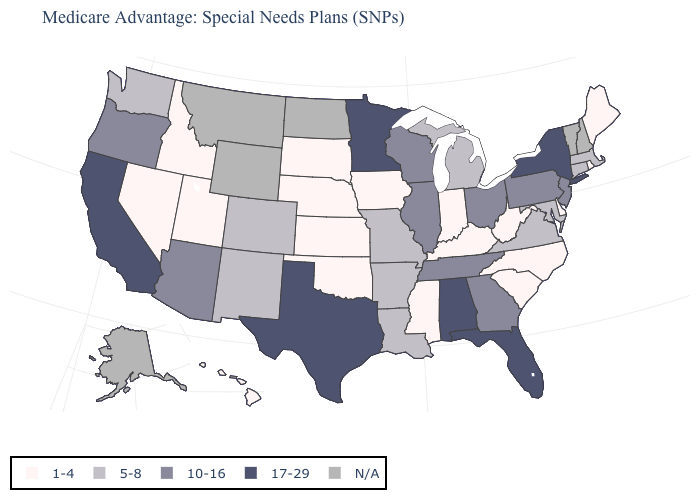Does Iowa have the lowest value in the USA?
Be succinct. Yes. Name the states that have a value in the range N/A?
Quick response, please. Alaska, Montana, North Dakota, New Hampshire, Vermont, Wyoming. Does the first symbol in the legend represent the smallest category?
Concise answer only. Yes. What is the value of Missouri?
Answer briefly. 5-8. Which states have the lowest value in the MidWest?
Give a very brief answer. Iowa, Indiana, Kansas, Nebraska, South Dakota. What is the value of New Mexico?
Short answer required. 5-8. Among the states that border Connecticut , does Massachusetts have the highest value?
Keep it brief. No. What is the lowest value in the South?
Answer briefly. 1-4. Is the legend a continuous bar?
Concise answer only. No. Does the first symbol in the legend represent the smallest category?
Write a very short answer. Yes. Name the states that have a value in the range 10-16?
Give a very brief answer. Arizona, Georgia, Illinois, New Jersey, Ohio, Oregon, Pennsylvania, Tennessee, Wisconsin. Name the states that have a value in the range 5-8?
Answer briefly. Arkansas, Colorado, Connecticut, Louisiana, Massachusetts, Maryland, Michigan, Missouri, New Mexico, Virginia, Washington. Does the map have missing data?
Write a very short answer. Yes. 